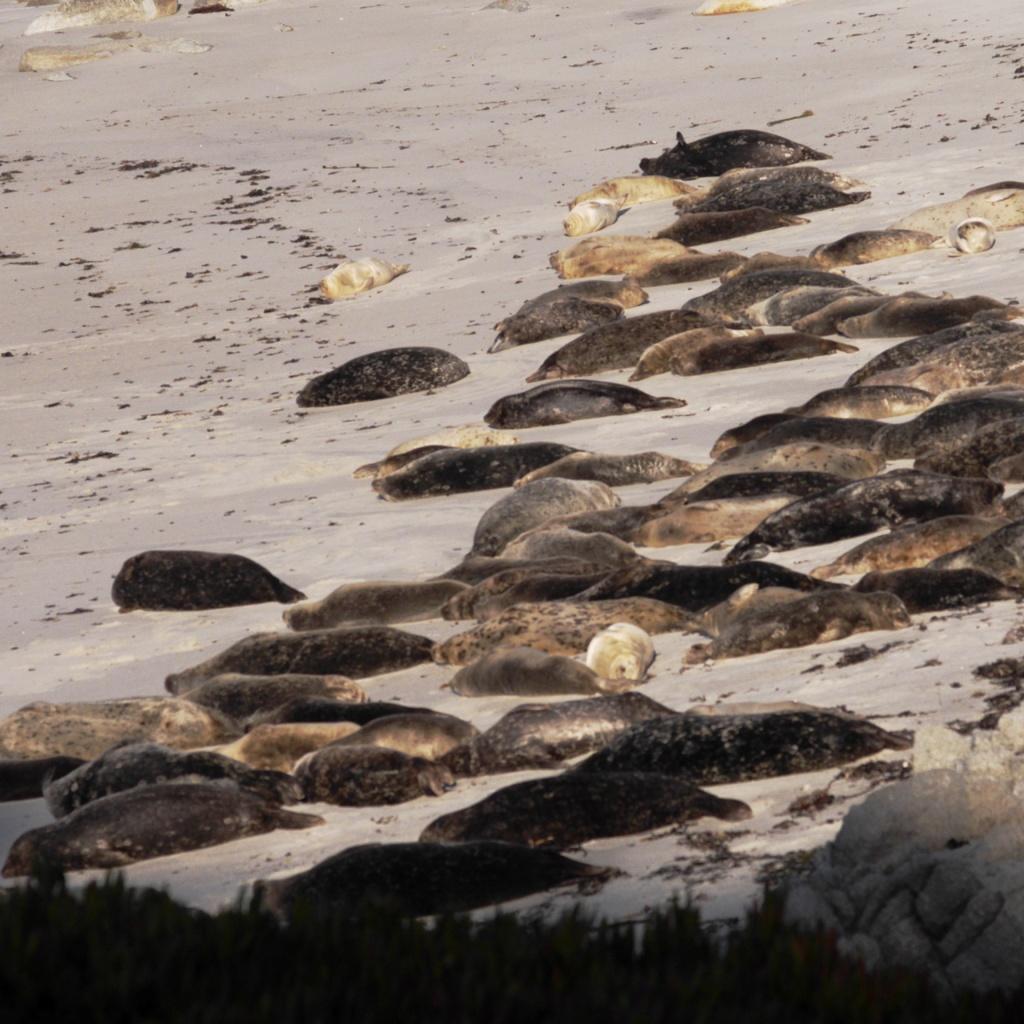How would you summarize this image in a sentence or two? In this image there are a few animals on the surface, at the bottom of the image there are a few plants. 